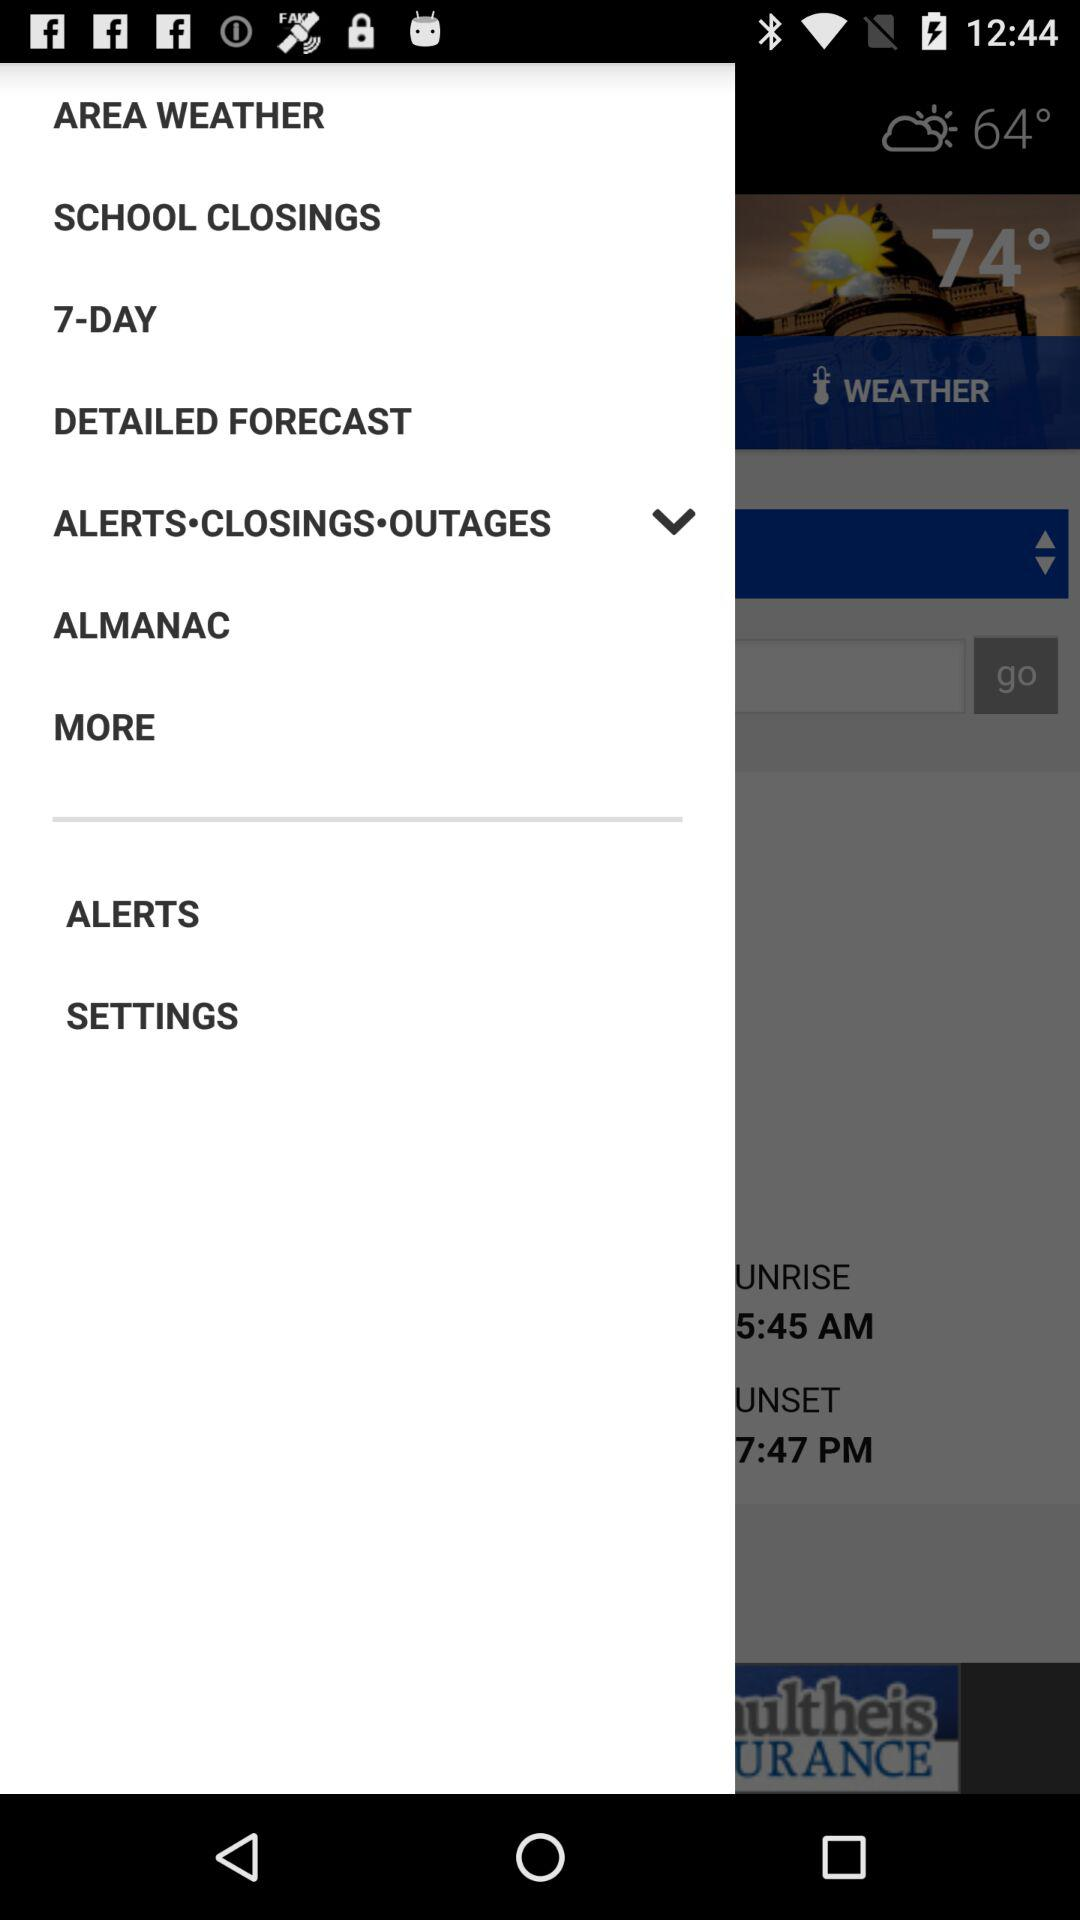What is the difference in temperature between the current temperature and the high temperature?
Answer the question using a single word or phrase. 10° 